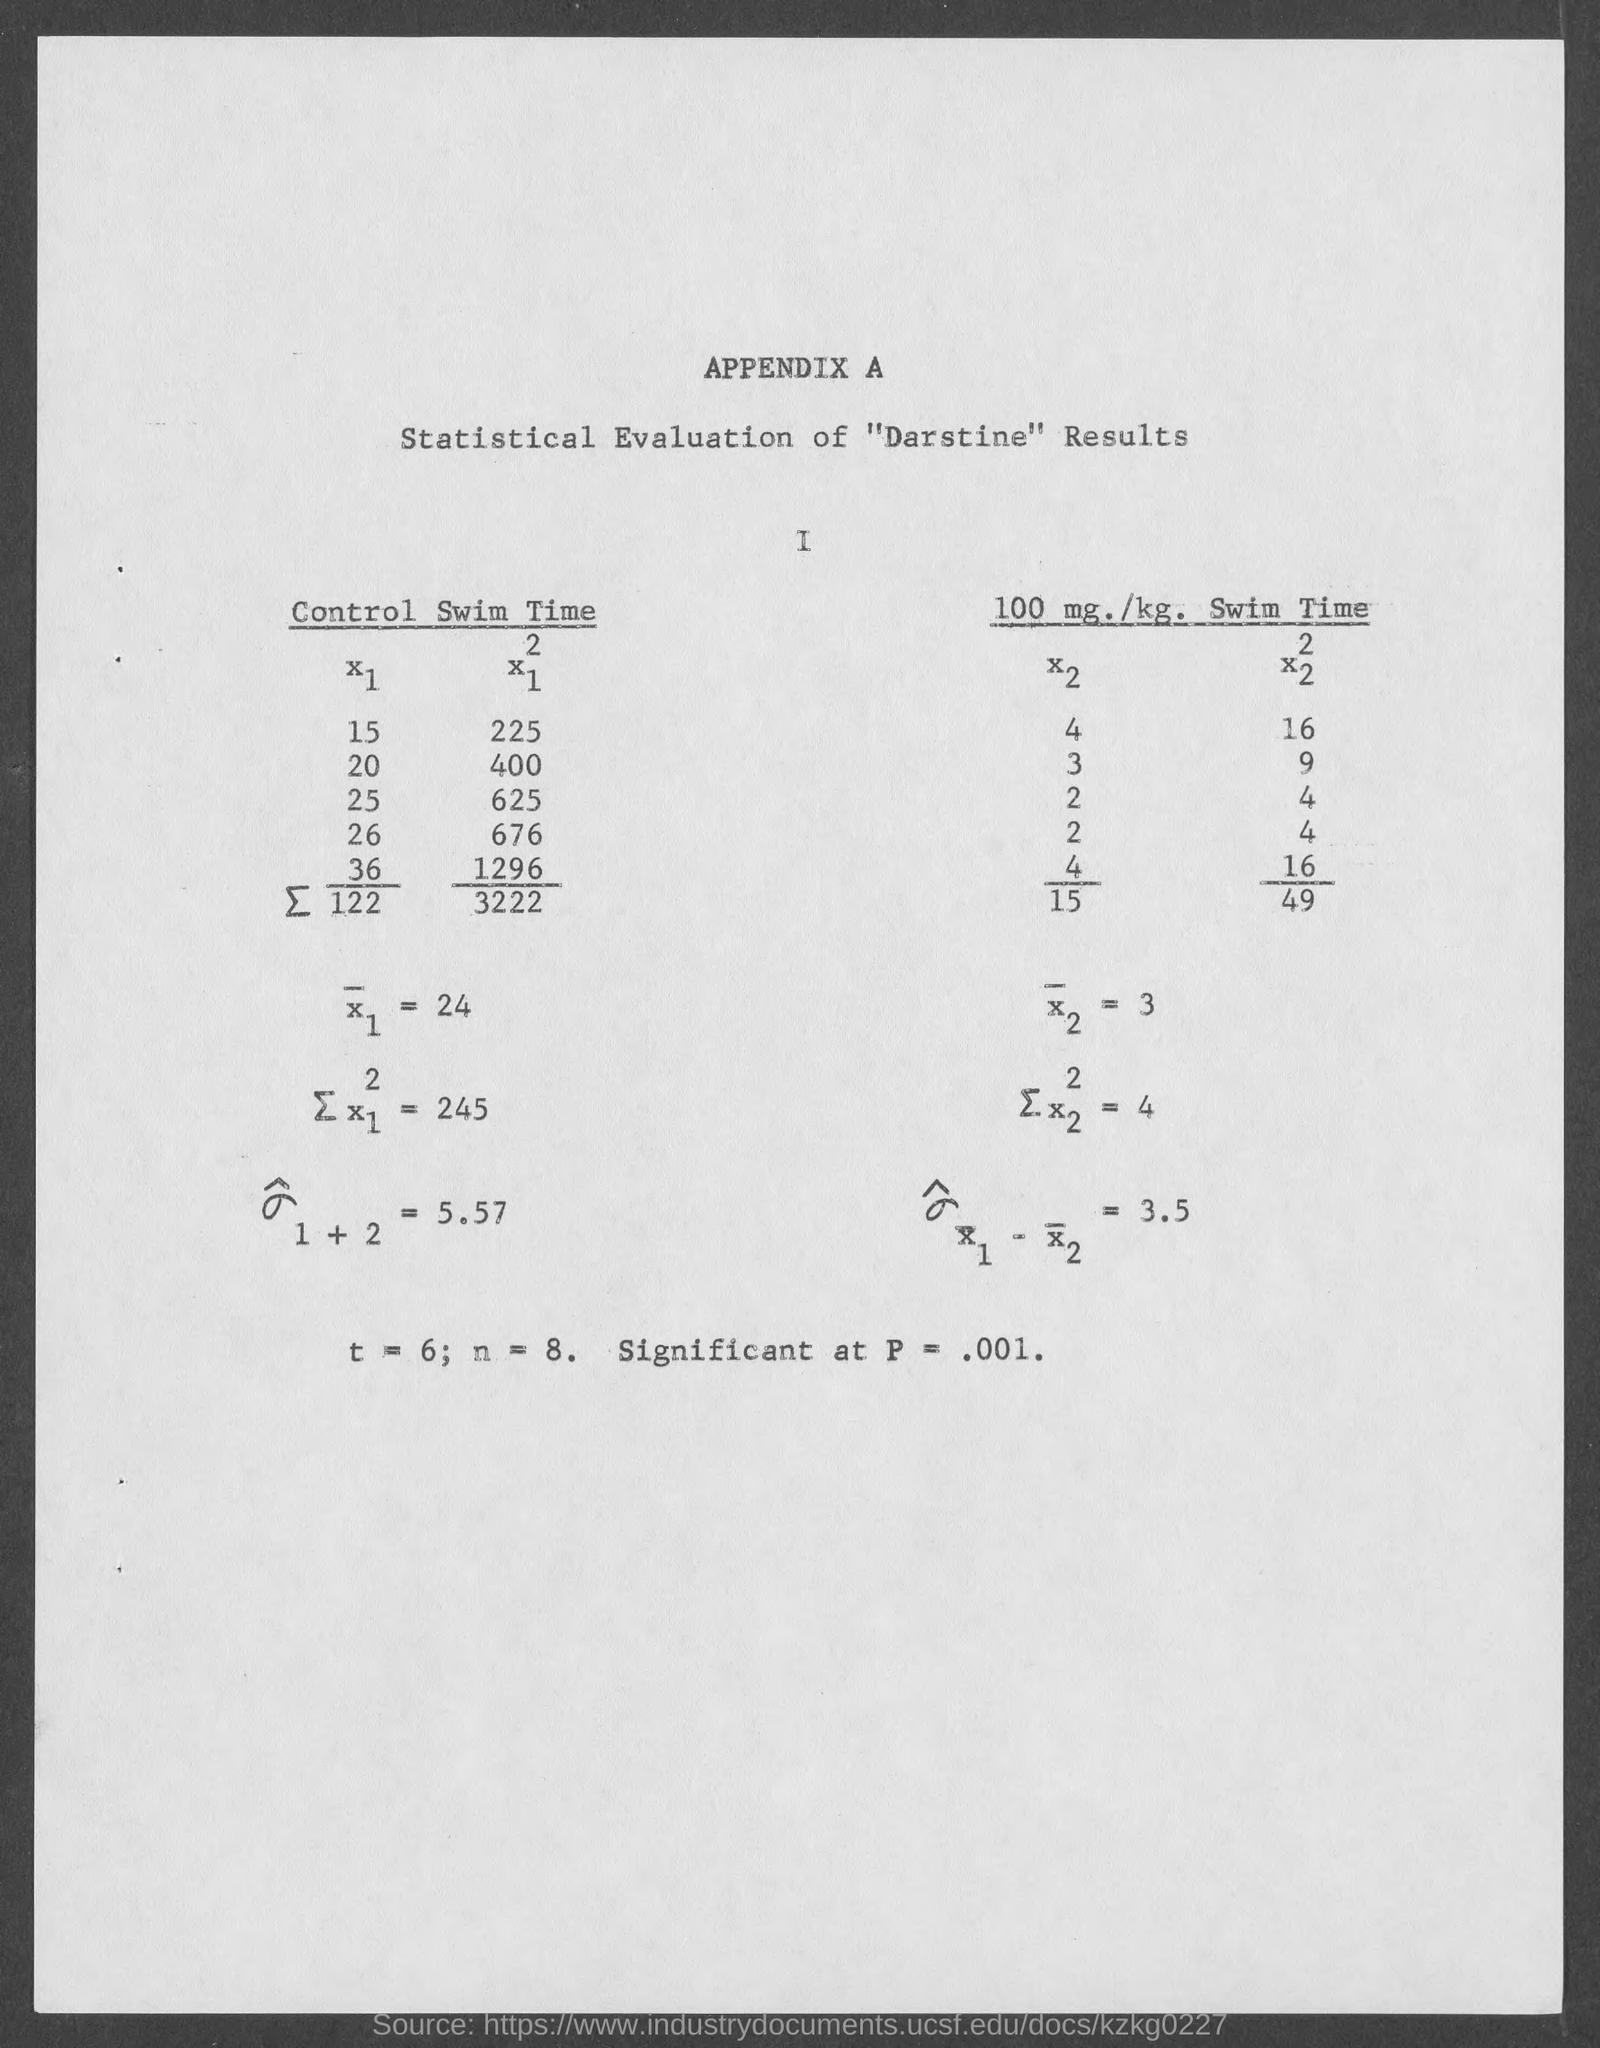Give some essential details in this illustration. The value of n is equal to 8 using the range 8.. The result is considered significant at a level of p < .001, indicating that there is strong evidence to support the conclusion that there is a positive relationship between access to technology and academic performance in math and science for gifted and talented students. 